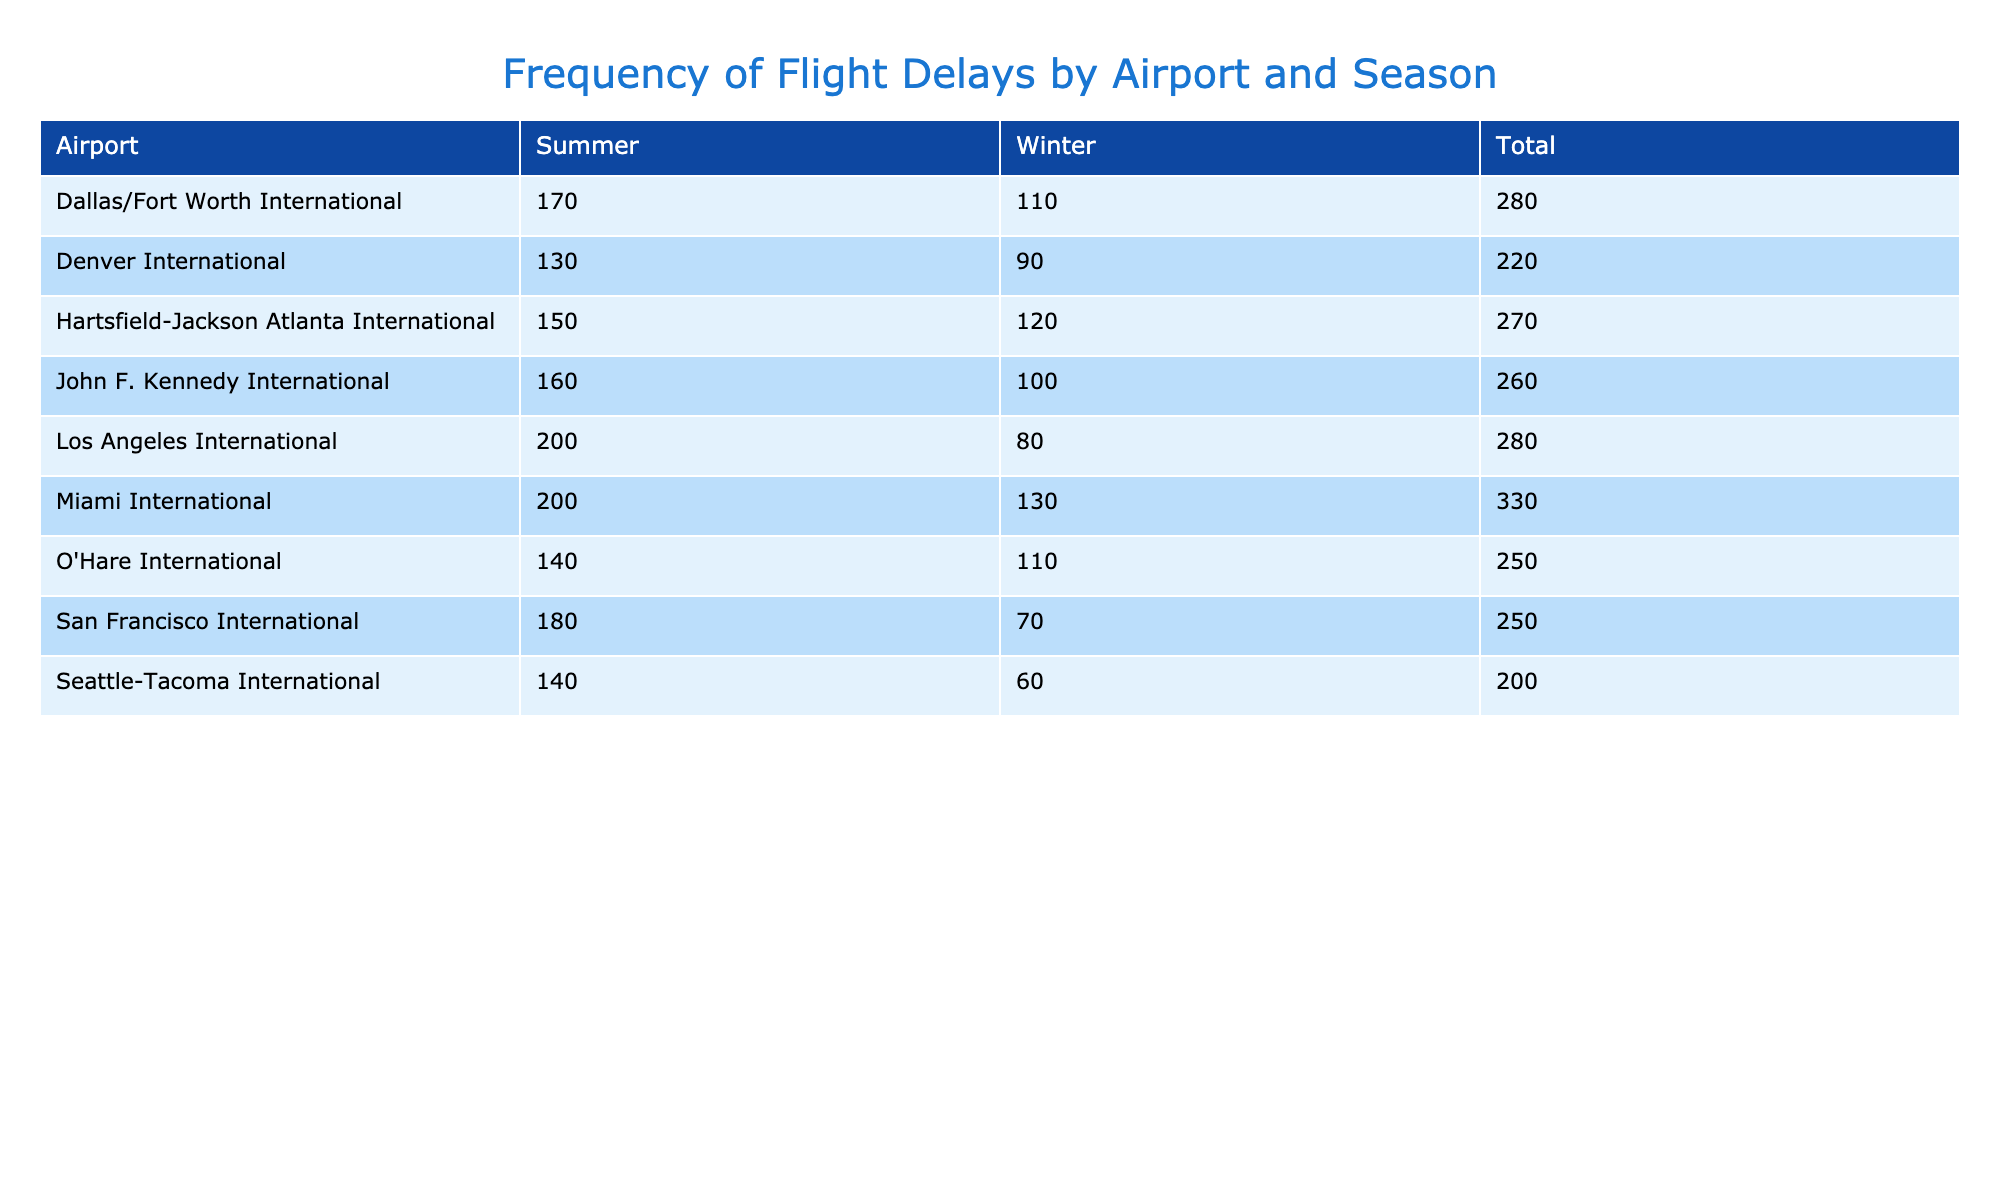What is the total number of delayed flights at Hartsfield-Jackson Atlanta International in winter? From the table, we can see that the number of delayed flights in winter at Hartsfield-Jackson Atlanta International is 120.
Answer: 120 Which airport had the highest number of delayed flights in the summer season? Looking across the summer column, Miami International has 200 delayed flights, which is the highest among all airports.
Answer: Miami International What is the difference in the number of delayed flights between summer and winter for Los Angeles International? For Los Angeles International, there are 200 delayed flights in summer and 80 in winter. The difference is 200 - 80 = 120.
Answer: 120 Is there a seasonal pattern indicating that delays are generally higher in summer compared to winter across all airports? By checking the total delayed flights for each season from the table, we find that summer has 1,210 delayed flights and winter has 1,030, indicating that summer delays are higher.
Answer: Yes What is the average number of delayed flights in winter across all the airports listed? Summing the delayed flights in winter (120 + 80 + 110 + 90 + 100 + 70 + 60 + 130 + 110) gives us 1,020. Since there are 9 airports, the average is 1,020 / 9 = 113.33.
Answer: 113.33 Which airport experienced the least number of delays in winter? The delays in winter for each airport are: 120 (Hartsfield-Jackson), 80 (Los Angeles), 110 (O'Hare), 90 (Denver), 100 (JFK), 70 (San Francisco), 60 (Seattle-Tacoma), 130 (Miami), and 110 (Dallas/Fort Worth). Seattle-Tacoma International had the least at 60.
Answer: Seattle-Tacoma International What is the total number of delayed flights for all airports in the summer? By summing the summer delayed flights (150 + 200 + 140 + 130 + 160 + 180 + 140 + 200 + 170), we get a total of 1,210 delayed flights in summer.
Answer: 1,210 Is it true that all airports had more delayed flights in summer compared to winter? Comparing the delayed flights for each airport in both seasons, we can see that while summer generally has higher numbers, Seattle-Tacoma International had fewer delays in summer (140) compared to winter (60), so the statement is false.
Answer: No What is the highest number of delayed flights recorded in the entire table? The highest number of delayed flights recorded in the table is 200 at Miami International for the summer season.
Answer: 200 